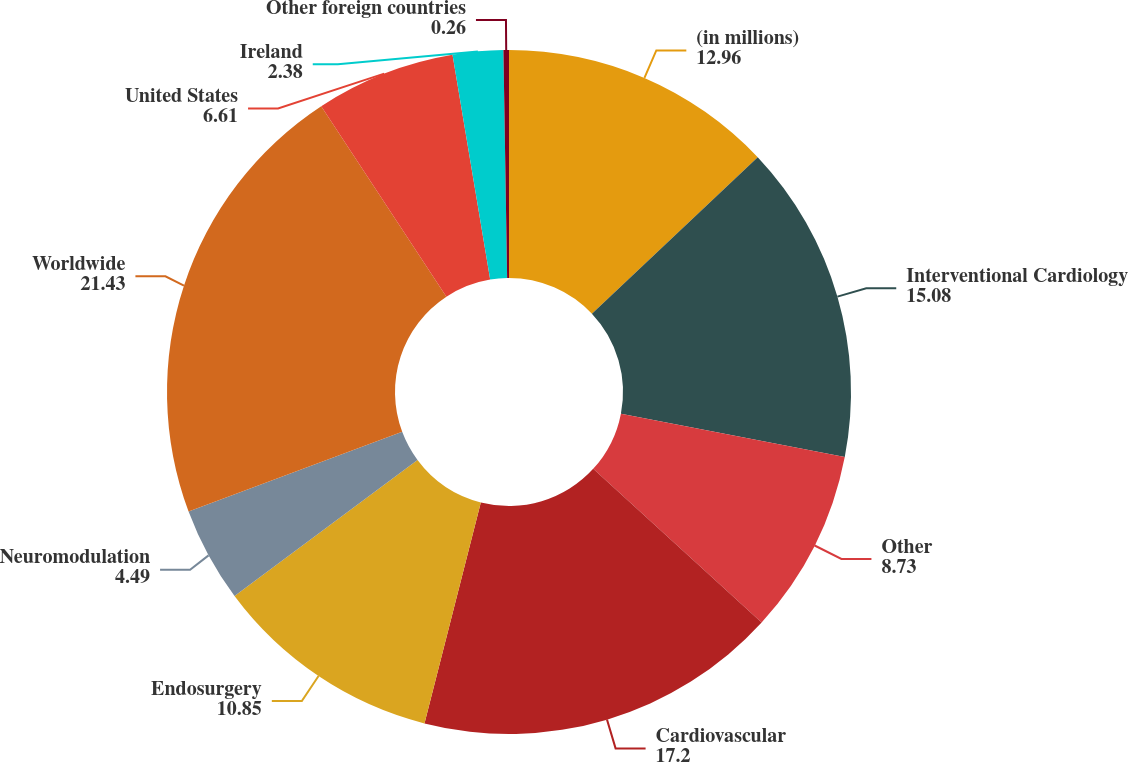Convert chart to OTSL. <chart><loc_0><loc_0><loc_500><loc_500><pie_chart><fcel>(in millions)<fcel>Interventional Cardiology<fcel>Other<fcel>Cardiovascular<fcel>Endosurgery<fcel>Neuromodulation<fcel>Worldwide<fcel>United States<fcel>Ireland<fcel>Other foreign countries<nl><fcel>12.96%<fcel>15.08%<fcel>8.73%<fcel>17.2%<fcel>10.85%<fcel>4.49%<fcel>21.43%<fcel>6.61%<fcel>2.38%<fcel>0.26%<nl></chart> 